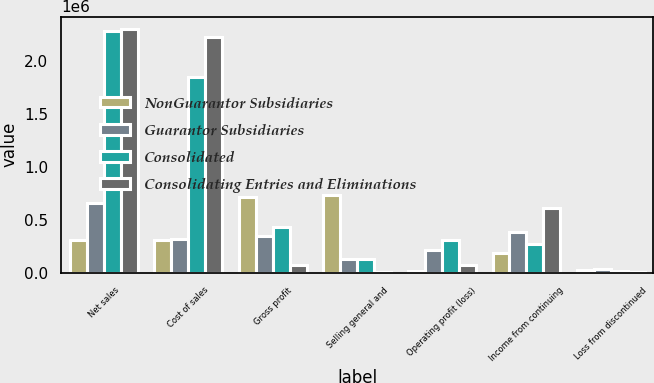Convert chart to OTSL. <chart><loc_0><loc_0><loc_500><loc_500><stacked_bar_chart><ecel><fcel>Net sales<fcel>Cost of sales<fcel>Gross profit<fcel>Selling general and<fcel>Operating profit (loss)<fcel>Income from continuing<fcel>Loss from discontinued<nl><fcel>NonGuarantor Subsidiaries<fcel>306333<fcel>306333<fcel>716505<fcel>730116<fcel>13611<fcel>188981<fcel>24300<nl><fcel>Guarantor Subsidiaries<fcel>661270<fcel>318326<fcel>342944<fcel>129978<fcel>212966<fcel>379877<fcel>31792<nl><fcel>Consolidated<fcel>2.28483e+06<fcel>1.84922e+06<fcel>435612<fcel>124174<fcel>311438<fcel>274540<fcel>15655<nl><fcel>Consolidating Entries and Eliminations<fcel>2.30747e+06<fcel>2.23245e+06<fcel>75014<fcel>4336<fcel>70678<fcel>610955<fcel>3985<nl></chart> 